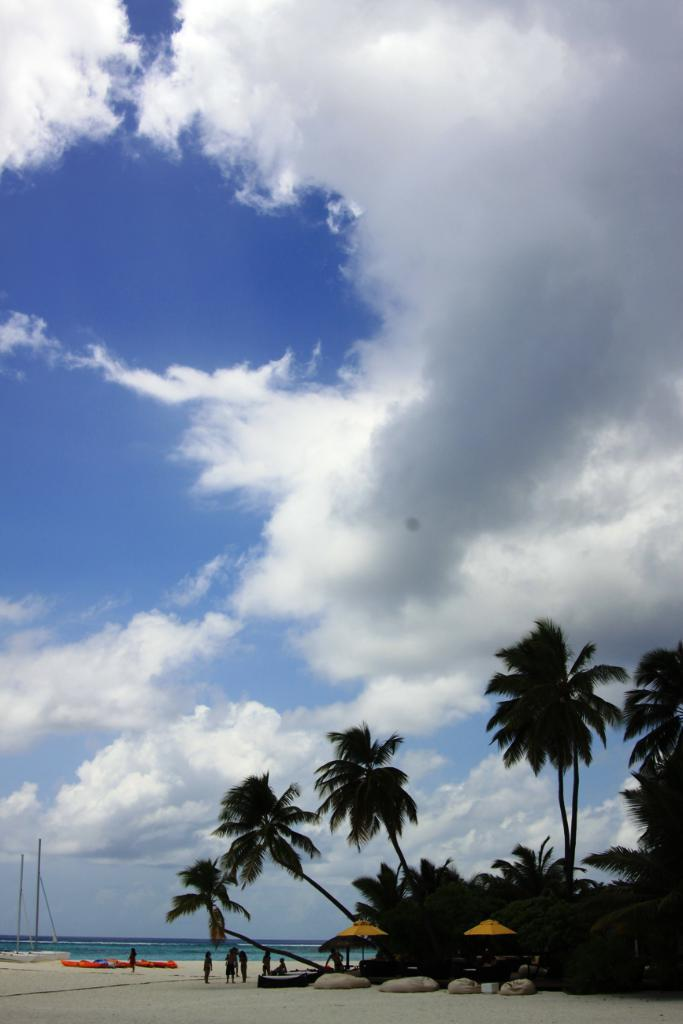What type of natural elements can be seen in the image? There are trees and water visible in the image. Can you describe the people in the image? There is a group of people in the image. What is visible in the background of the image? The sky is visible in the image, and there are clouds in the sky. What type of sticks can be seen in the hands of the tiger in the image? There is no tiger present in the image, and therefore no sticks can be seen in its hands. 